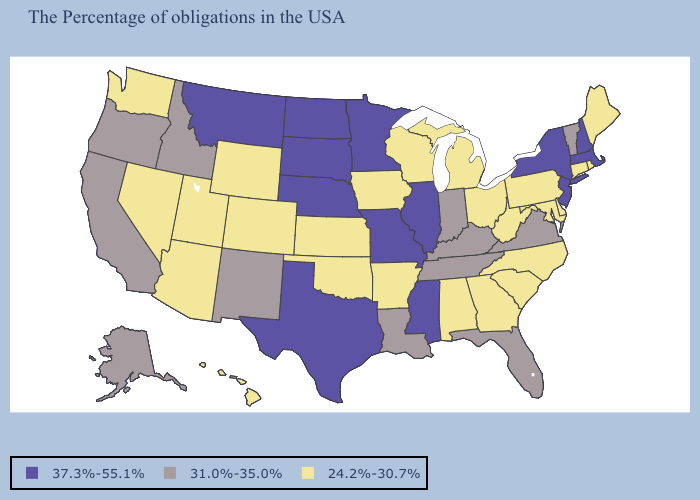What is the lowest value in the South?
Short answer required. 24.2%-30.7%. What is the value of California?
Concise answer only. 31.0%-35.0%. Which states have the highest value in the USA?
Write a very short answer. Massachusetts, New Hampshire, New York, New Jersey, Illinois, Mississippi, Missouri, Minnesota, Nebraska, Texas, South Dakota, North Dakota, Montana. What is the value of Montana?
Quick response, please. 37.3%-55.1%. Among the states that border Nevada , which have the lowest value?
Answer briefly. Utah, Arizona. Does Mississippi have the same value as Virginia?
Give a very brief answer. No. What is the value of Rhode Island?
Answer briefly. 24.2%-30.7%. What is the lowest value in the USA?
Write a very short answer. 24.2%-30.7%. Among the states that border California , which have the lowest value?
Concise answer only. Arizona, Nevada. What is the lowest value in the Northeast?
Answer briefly. 24.2%-30.7%. Does Texas have the lowest value in the South?
Short answer required. No. Which states have the lowest value in the USA?
Write a very short answer. Maine, Rhode Island, Connecticut, Delaware, Maryland, Pennsylvania, North Carolina, South Carolina, West Virginia, Ohio, Georgia, Michigan, Alabama, Wisconsin, Arkansas, Iowa, Kansas, Oklahoma, Wyoming, Colorado, Utah, Arizona, Nevada, Washington, Hawaii. Among the states that border Nevada , does Utah have the lowest value?
Write a very short answer. Yes. Name the states that have a value in the range 24.2%-30.7%?
Quick response, please. Maine, Rhode Island, Connecticut, Delaware, Maryland, Pennsylvania, North Carolina, South Carolina, West Virginia, Ohio, Georgia, Michigan, Alabama, Wisconsin, Arkansas, Iowa, Kansas, Oklahoma, Wyoming, Colorado, Utah, Arizona, Nevada, Washington, Hawaii. 